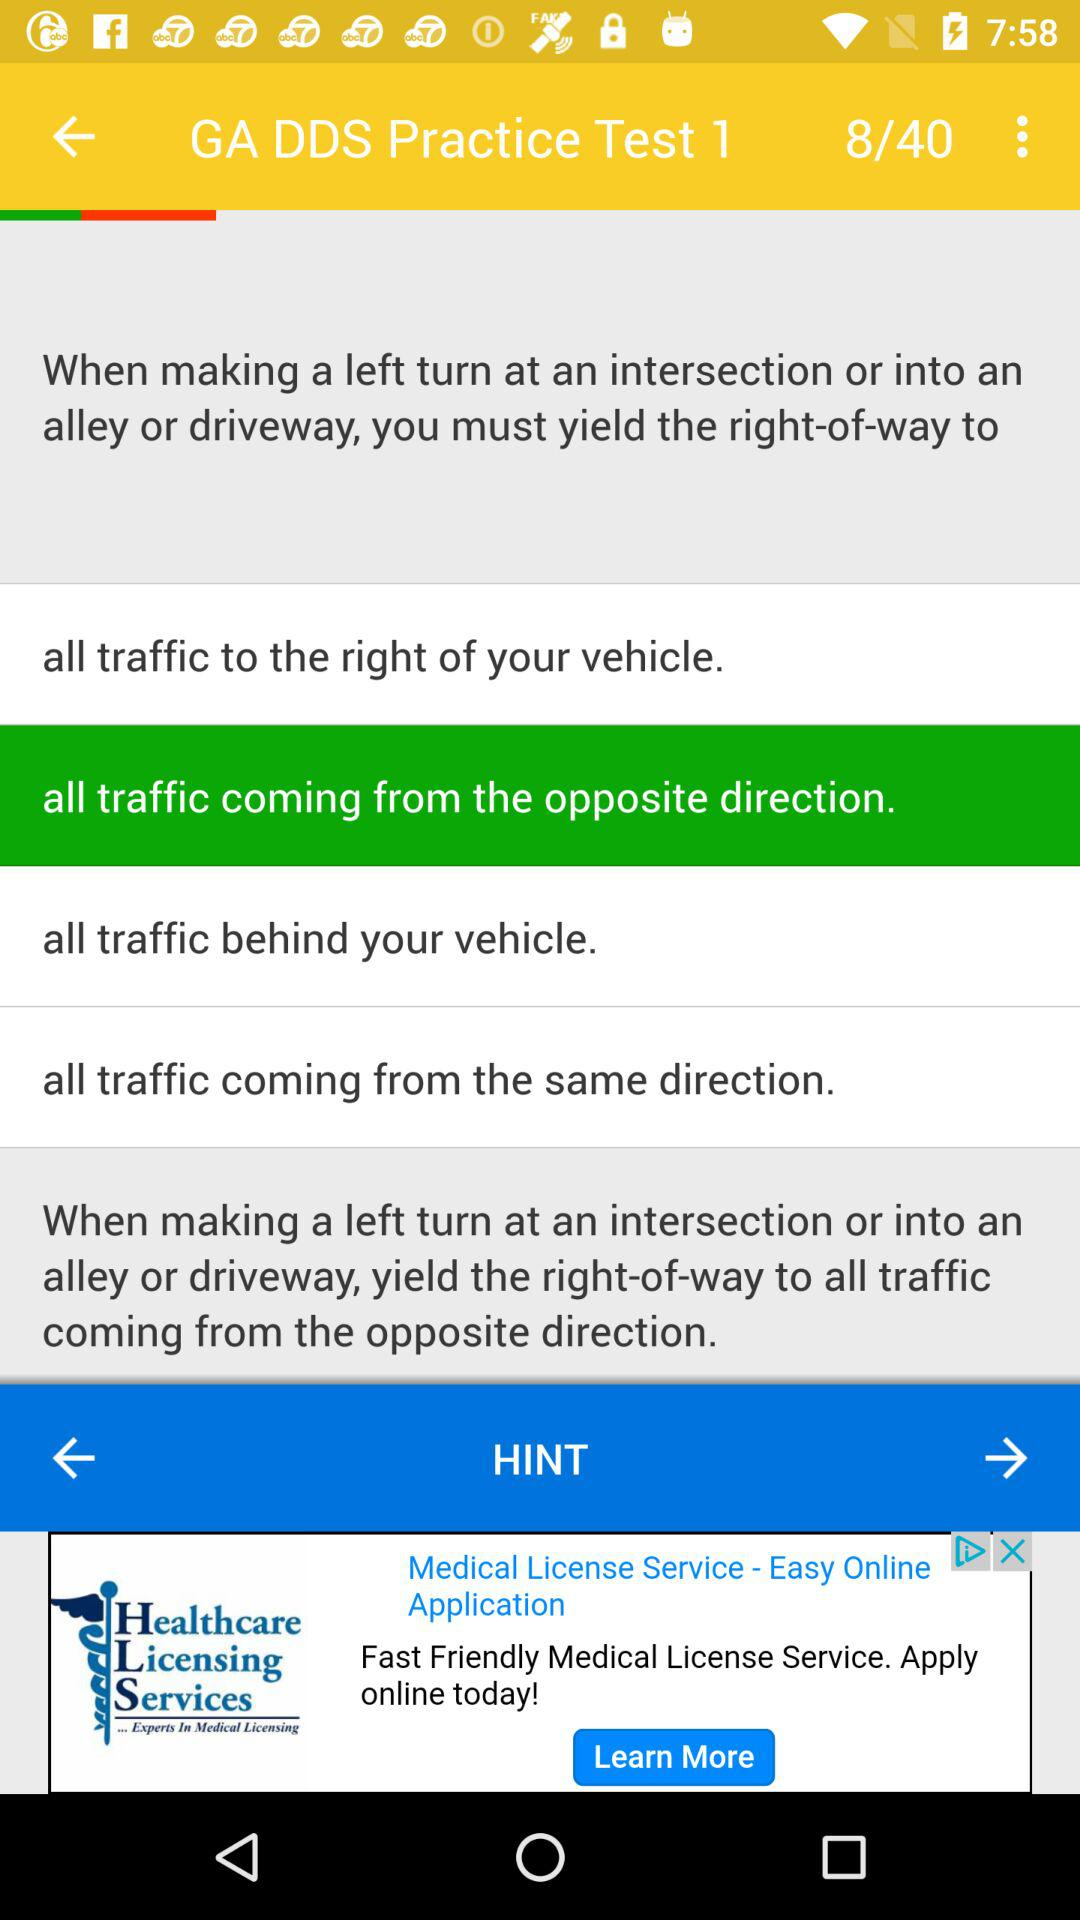At which question am I? You are at question 8. 